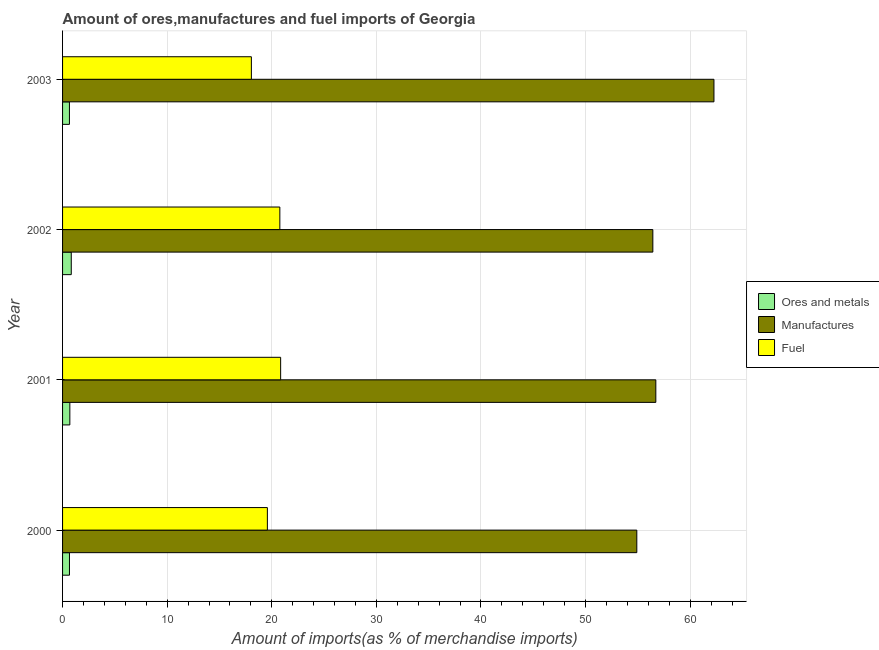Are the number of bars per tick equal to the number of legend labels?
Provide a succinct answer. Yes. Are the number of bars on each tick of the Y-axis equal?
Make the answer very short. Yes. How many bars are there on the 4th tick from the bottom?
Your response must be concise. 3. What is the label of the 1st group of bars from the top?
Give a very brief answer. 2003. In how many cases, is the number of bars for a given year not equal to the number of legend labels?
Give a very brief answer. 0. What is the percentage of manufactures imports in 2002?
Offer a very short reply. 56.43. Across all years, what is the maximum percentage of manufactures imports?
Ensure brevity in your answer.  62.27. Across all years, what is the minimum percentage of ores and metals imports?
Your answer should be compact. 0.66. In which year was the percentage of ores and metals imports maximum?
Ensure brevity in your answer.  2002. In which year was the percentage of fuel imports minimum?
Your answer should be very brief. 2003. What is the total percentage of fuel imports in the graph?
Your answer should be compact. 79.25. What is the difference between the percentage of manufactures imports in 2000 and that in 2003?
Make the answer very short. -7.38. What is the difference between the percentage of ores and metals imports in 2000 and the percentage of fuel imports in 2003?
Provide a succinct answer. -17.39. What is the average percentage of manufactures imports per year?
Your answer should be compact. 57.58. In the year 2003, what is the difference between the percentage of ores and metals imports and percentage of fuel imports?
Your answer should be compact. -17.39. In how many years, is the percentage of fuel imports greater than 48 %?
Make the answer very short. 0. What is the ratio of the percentage of manufactures imports in 2000 to that in 2003?
Offer a very short reply. 0.88. Is the percentage of manufactures imports in 2001 less than that in 2003?
Make the answer very short. Yes. Is the difference between the percentage of ores and metals imports in 2002 and 2003 greater than the difference between the percentage of fuel imports in 2002 and 2003?
Keep it short and to the point. No. What is the difference between the highest and the second highest percentage of fuel imports?
Provide a short and direct response. 0.08. What is the difference between the highest and the lowest percentage of ores and metals imports?
Keep it short and to the point. 0.17. What does the 3rd bar from the top in 2003 represents?
Keep it short and to the point. Ores and metals. What does the 2nd bar from the bottom in 2001 represents?
Give a very brief answer. Manufactures. Is it the case that in every year, the sum of the percentage of ores and metals imports and percentage of manufactures imports is greater than the percentage of fuel imports?
Ensure brevity in your answer.  Yes. How many bars are there?
Offer a terse response. 12. How many years are there in the graph?
Keep it short and to the point. 4. Are the values on the major ticks of X-axis written in scientific E-notation?
Make the answer very short. No. Does the graph contain any zero values?
Your answer should be very brief. No. Does the graph contain grids?
Make the answer very short. Yes. Where does the legend appear in the graph?
Your response must be concise. Center right. How many legend labels are there?
Your response must be concise. 3. How are the legend labels stacked?
Offer a terse response. Vertical. What is the title of the graph?
Your answer should be compact. Amount of ores,manufactures and fuel imports of Georgia. What is the label or title of the X-axis?
Give a very brief answer. Amount of imports(as % of merchandise imports). What is the Amount of imports(as % of merchandise imports) of Ores and metals in 2000?
Ensure brevity in your answer.  0.66. What is the Amount of imports(as % of merchandise imports) in Manufactures in 2000?
Your answer should be very brief. 54.9. What is the Amount of imports(as % of merchandise imports) of Fuel in 2000?
Your answer should be compact. 19.58. What is the Amount of imports(as % of merchandise imports) in Ores and metals in 2001?
Provide a succinct answer. 0.7. What is the Amount of imports(as % of merchandise imports) in Manufactures in 2001?
Your answer should be very brief. 56.71. What is the Amount of imports(as % of merchandise imports) in Fuel in 2001?
Provide a succinct answer. 20.85. What is the Amount of imports(as % of merchandise imports) in Ores and metals in 2002?
Your answer should be compact. 0.83. What is the Amount of imports(as % of merchandise imports) of Manufactures in 2002?
Offer a very short reply. 56.43. What is the Amount of imports(as % of merchandise imports) in Fuel in 2002?
Provide a short and direct response. 20.77. What is the Amount of imports(as % of merchandise imports) of Ores and metals in 2003?
Your response must be concise. 0.66. What is the Amount of imports(as % of merchandise imports) of Manufactures in 2003?
Ensure brevity in your answer.  62.27. What is the Amount of imports(as % of merchandise imports) of Fuel in 2003?
Provide a succinct answer. 18.05. Across all years, what is the maximum Amount of imports(as % of merchandise imports) in Ores and metals?
Ensure brevity in your answer.  0.83. Across all years, what is the maximum Amount of imports(as % of merchandise imports) in Manufactures?
Offer a very short reply. 62.27. Across all years, what is the maximum Amount of imports(as % of merchandise imports) in Fuel?
Provide a short and direct response. 20.85. Across all years, what is the minimum Amount of imports(as % of merchandise imports) in Ores and metals?
Keep it short and to the point. 0.66. Across all years, what is the minimum Amount of imports(as % of merchandise imports) in Manufactures?
Provide a succinct answer. 54.9. Across all years, what is the minimum Amount of imports(as % of merchandise imports) in Fuel?
Your response must be concise. 18.05. What is the total Amount of imports(as % of merchandise imports) of Ores and metals in the graph?
Offer a terse response. 2.84. What is the total Amount of imports(as % of merchandise imports) of Manufactures in the graph?
Make the answer very short. 230.31. What is the total Amount of imports(as % of merchandise imports) of Fuel in the graph?
Ensure brevity in your answer.  79.25. What is the difference between the Amount of imports(as % of merchandise imports) of Ores and metals in 2000 and that in 2001?
Your answer should be compact. -0.04. What is the difference between the Amount of imports(as % of merchandise imports) in Manufactures in 2000 and that in 2001?
Keep it short and to the point. -1.82. What is the difference between the Amount of imports(as % of merchandise imports) of Fuel in 2000 and that in 2001?
Provide a succinct answer. -1.27. What is the difference between the Amount of imports(as % of merchandise imports) of Ores and metals in 2000 and that in 2002?
Provide a short and direct response. -0.17. What is the difference between the Amount of imports(as % of merchandise imports) in Manufactures in 2000 and that in 2002?
Your answer should be compact. -1.53. What is the difference between the Amount of imports(as % of merchandise imports) in Fuel in 2000 and that in 2002?
Your answer should be compact. -1.19. What is the difference between the Amount of imports(as % of merchandise imports) of Ores and metals in 2000 and that in 2003?
Your answer should be very brief. 0. What is the difference between the Amount of imports(as % of merchandise imports) in Manufactures in 2000 and that in 2003?
Ensure brevity in your answer.  -7.37. What is the difference between the Amount of imports(as % of merchandise imports) of Fuel in 2000 and that in 2003?
Provide a succinct answer. 1.53. What is the difference between the Amount of imports(as % of merchandise imports) in Ores and metals in 2001 and that in 2002?
Your answer should be compact. -0.14. What is the difference between the Amount of imports(as % of merchandise imports) of Manufactures in 2001 and that in 2002?
Offer a very short reply. 0.28. What is the difference between the Amount of imports(as % of merchandise imports) of Fuel in 2001 and that in 2002?
Offer a very short reply. 0.08. What is the difference between the Amount of imports(as % of merchandise imports) in Ores and metals in 2001 and that in 2003?
Offer a terse response. 0.04. What is the difference between the Amount of imports(as % of merchandise imports) of Manufactures in 2001 and that in 2003?
Provide a short and direct response. -5.56. What is the difference between the Amount of imports(as % of merchandise imports) of Fuel in 2001 and that in 2003?
Give a very brief answer. 2.8. What is the difference between the Amount of imports(as % of merchandise imports) in Ores and metals in 2002 and that in 2003?
Your answer should be very brief. 0.17. What is the difference between the Amount of imports(as % of merchandise imports) of Manufactures in 2002 and that in 2003?
Your response must be concise. -5.84. What is the difference between the Amount of imports(as % of merchandise imports) in Fuel in 2002 and that in 2003?
Make the answer very short. 2.72. What is the difference between the Amount of imports(as % of merchandise imports) of Ores and metals in 2000 and the Amount of imports(as % of merchandise imports) of Manufactures in 2001?
Provide a short and direct response. -56.05. What is the difference between the Amount of imports(as % of merchandise imports) in Ores and metals in 2000 and the Amount of imports(as % of merchandise imports) in Fuel in 2001?
Your answer should be compact. -20.19. What is the difference between the Amount of imports(as % of merchandise imports) of Manufactures in 2000 and the Amount of imports(as % of merchandise imports) of Fuel in 2001?
Provide a short and direct response. 34.05. What is the difference between the Amount of imports(as % of merchandise imports) in Ores and metals in 2000 and the Amount of imports(as % of merchandise imports) in Manufactures in 2002?
Ensure brevity in your answer.  -55.77. What is the difference between the Amount of imports(as % of merchandise imports) in Ores and metals in 2000 and the Amount of imports(as % of merchandise imports) in Fuel in 2002?
Give a very brief answer. -20.11. What is the difference between the Amount of imports(as % of merchandise imports) of Manufactures in 2000 and the Amount of imports(as % of merchandise imports) of Fuel in 2002?
Your answer should be compact. 34.13. What is the difference between the Amount of imports(as % of merchandise imports) in Ores and metals in 2000 and the Amount of imports(as % of merchandise imports) in Manufactures in 2003?
Make the answer very short. -61.61. What is the difference between the Amount of imports(as % of merchandise imports) in Ores and metals in 2000 and the Amount of imports(as % of merchandise imports) in Fuel in 2003?
Offer a terse response. -17.39. What is the difference between the Amount of imports(as % of merchandise imports) in Manufactures in 2000 and the Amount of imports(as % of merchandise imports) in Fuel in 2003?
Your response must be concise. 36.85. What is the difference between the Amount of imports(as % of merchandise imports) in Ores and metals in 2001 and the Amount of imports(as % of merchandise imports) in Manufactures in 2002?
Provide a succinct answer. -55.73. What is the difference between the Amount of imports(as % of merchandise imports) in Ores and metals in 2001 and the Amount of imports(as % of merchandise imports) in Fuel in 2002?
Keep it short and to the point. -20.07. What is the difference between the Amount of imports(as % of merchandise imports) of Manufactures in 2001 and the Amount of imports(as % of merchandise imports) of Fuel in 2002?
Make the answer very short. 35.94. What is the difference between the Amount of imports(as % of merchandise imports) of Ores and metals in 2001 and the Amount of imports(as % of merchandise imports) of Manufactures in 2003?
Provide a succinct answer. -61.58. What is the difference between the Amount of imports(as % of merchandise imports) in Ores and metals in 2001 and the Amount of imports(as % of merchandise imports) in Fuel in 2003?
Your answer should be compact. -17.35. What is the difference between the Amount of imports(as % of merchandise imports) in Manufactures in 2001 and the Amount of imports(as % of merchandise imports) in Fuel in 2003?
Your response must be concise. 38.67. What is the difference between the Amount of imports(as % of merchandise imports) in Ores and metals in 2002 and the Amount of imports(as % of merchandise imports) in Manufactures in 2003?
Keep it short and to the point. -61.44. What is the difference between the Amount of imports(as % of merchandise imports) in Ores and metals in 2002 and the Amount of imports(as % of merchandise imports) in Fuel in 2003?
Your response must be concise. -17.22. What is the difference between the Amount of imports(as % of merchandise imports) in Manufactures in 2002 and the Amount of imports(as % of merchandise imports) in Fuel in 2003?
Keep it short and to the point. 38.38. What is the average Amount of imports(as % of merchandise imports) of Ores and metals per year?
Your response must be concise. 0.71. What is the average Amount of imports(as % of merchandise imports) in Manufactures per year?
Offer a very short reply. 57.58. What is the average Amount of imports(as % of merchandise imports) of Fuel per year?
Your answer should be compact. 19.81. In the year 2000, what is the difference between the Amount of imports(as % of merchandise imports) of Ores and metals and Amount of imports(as % of merchandise imports) of Manufactures?
Offer a terse response. -54.24. In the year 2000, what is the difference between the Amount of imports(as % of merchandise imports) in Ores and metals and Amount of imports(as % of merchandise imports) in Fuel?
Provide a succinct answer. -18.92. In the year 2000, what is the difference between the Amount of imports(as % of merchandise imports) of Manufactures and Amount of imports(as % of merchandise imports) of Fuel?
Make the answer very short. 35.32. In the year 2001, what is the difference between the Amount of imports(as % of merchandise imports) in Ores and metals and Amount of imports(as % of merchandise imports) in Manufactures?
Your response must be concise. -56.02. In the year 2001, what is the difference between the Amount of imports(as % of merchandise imports) of Ores and metals and Amount of imports(as % of merchandise imports) of Fuel?
Your response must be concise. -20.15. In the year 2001, what is the difference between the Amount of imports(as % of merchandise imports) of Manufactures and Amount of imports(as % of merchandise imports) of Fuel?
Offer a terse response. 35.87. In the year 2002, what is the difference between the Amount of imports(as % of merchandise imports) in Ores and metals and Amount of imports(as % of merchandise imports) in Manufactures?
Make the answer very short. -55.6. In the year 2002, what is the difference between the Amount of imports(as % of merchandise imports) in Ores and metals and Amount of imports(as % of merchandise imports) in Fuel?
Your answer should be compact. -19.94. In the year 2002, what is the difference between the Amount of imports(as % of merchandise imports) in Manufactures and Amount of imports(as % of merchandise imports) in Fuel?
Keep it short and to the point. 35.66. In the year 2003, what is the difference between the Amount of imports(as % of merchandise imports) of Ores and metals and Amount of imports(as % of merchandise imports) of Manufactures?
Offer a terse response. -61.61. In the year 2003, what is the difference between the Amount of imports(as % of merchandise imports) in Ores and metals and Amount of imports(as % of merchandise imports) in Fuel?
Make the answer very short. -17.39. In the year 2003, what is the difference between the Amount of imports(as % of merchandise imports) of Manufactures and Amount of imports(as % of merchandise imports) of Fuel?
Ensure brevity in your answer.  44.22. What is the ratio of the Amount of imports(as % of merchandise imports) of Ores and metals in 2000 to that in 2001?
Offer a terse response. 0.95. What is the ratio of the Amount of imports(as % of merchandise imports) in Manufactures in 2000 to that in 2001?
Provide a short and direct response. 0.97. What is the ratio of the Amount of imports(as % of merchandise imports) in Fuel in 2000 to that in 2001?
Your response must be concise. 0.94. What is the ratio of the Amount of imports(as % of merchandise imports) in Ores and metals in 2000 to that in 2002?
Provide a short and direct response. 0.79. What is the ratio of the Amount of imports(as % of merchandise imports) in Manufactures in 2000 to that in 2002?
Ensure brevity in your answer.  0.97. What is the ratio of the Amount of imports(as % of merchandise imports) of Fuel in 2000 to that in 2002?
Offer a very short reply. 0.94. What is the ratio of the Amount of imports(as % of merchandise imports) in Manufactures in 2000 to that in 2003?
Your answer should be very brief. 0.88. What is the ratio of the Amount of imports(as % of merchandise imports) of Fuel in 2000 to that in 2003?
Offer a very short reply. 1.08. What is the ratio of the Amount of imports(as % of merchandise imports) of Ores and metals in 2001 to that in 2002?
Give a very brief answer. 0.84. What is the ratio of the Amount of imports(as % of merchandise imports) in Ores and metals in 2001 to that in 2003?
Provide a short and direct response. 1.06. What is the ratio of the Amount of imports(as % of merchandise imports) of Manufactures in 2001 to that in 2003?
Make the answer very short. 0.91. What is the ratio of the Amount of imports(as % of merchandise imports) in Fuel in 2001 to that in 2003?
Provide a short and direct response. 1.16. What is the ratio of the Amount of imports(as % of merchandise imports) in Ores and metals in 2002 to that in 2003?
Provide a short and direct response. 1.27. What is the ratio of the Amount of imports(as % of merchandise imports) in Manufactures in 2002 to that in 2003?
Give a very brief answer. 0.91. What is the ratio of the Amount of imports(as % of merchandise imports) in Fuel in 2002 to that in 2003?
Provide a short and direct response. 1.15. What is the difference between the highest and the second highest Amount of imports(as % of merchandise imports) of Ores and metals?
Provide a short and direct response. 0.14. What is the difference between the highest and the second highest Amount of imports(as % of merchandise imports) of Manufactures?
Your response must be concise. 5.56. What is the difference between the highest and the second highest Amount of imports(as % of merchandise imports) in Fuel?
Your answer should be compact. 0.08. What is the difference between the highest and the lowest Amount of imports(as % of merchandise imports) of Ores and metals?
Offer a terse response. 0.17. What is the difference between the highest and the lowest Amount of imports(as % of merchandise imports) of Manufactures?
Offer a very short reply. 7.37. What is the difference between the highest and the lowest Amount of imports(as % of merchandise imports) of Fuel?
Make the answer very short. 2.8. 